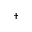<formula> <loc_0><loc_0><loc_500><loc_500>^ { \dagger }</formula> 